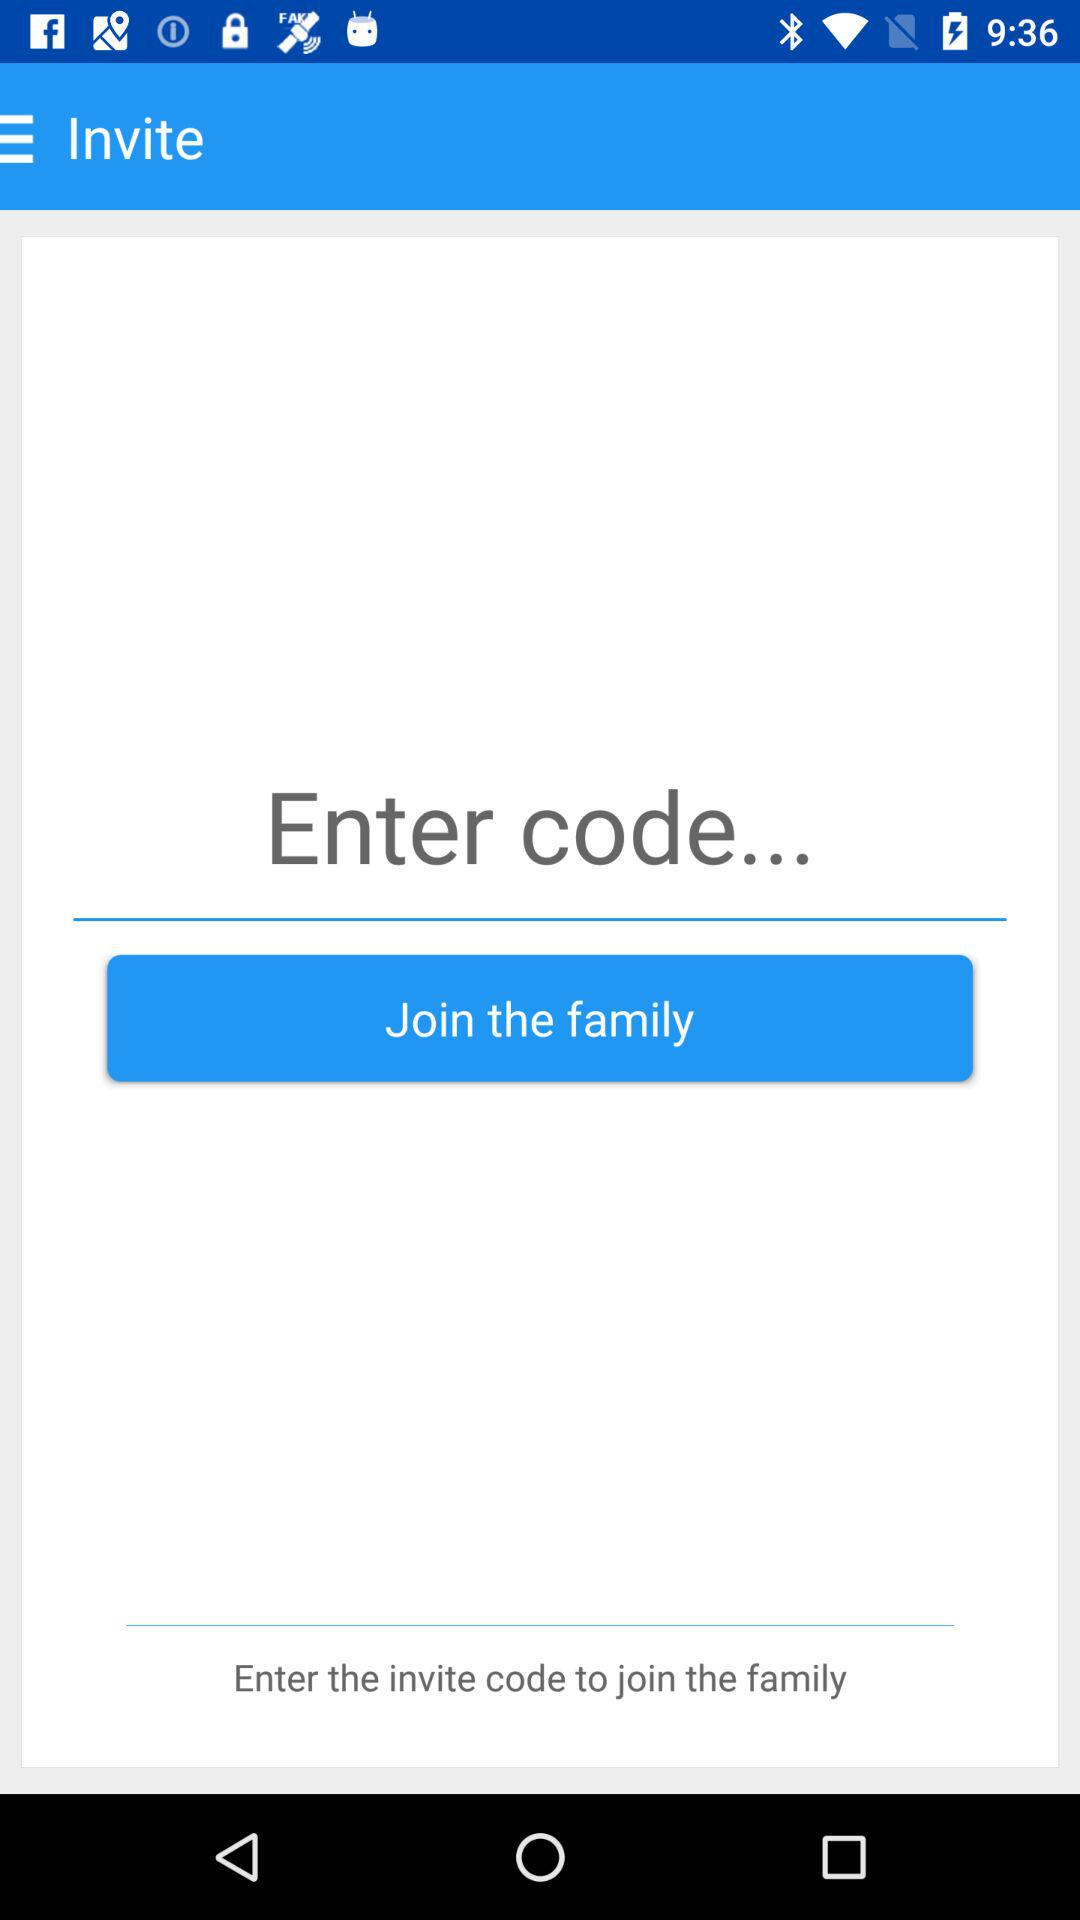What do we need to do to join the family? You need to enter the invite code to join the family. 